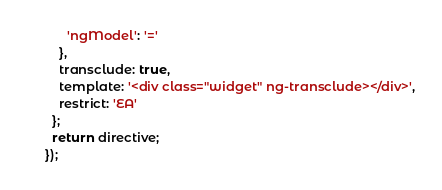<code> <loc_0><loc_0><loc_500><loc_500><_JavaScript_>      'ngModel': '='
    },
    transclude: true,
    template: '<div class="widget" ng-transclude></div>',
    restrict: 'EA'
  };
  return directive;
});
</code> 